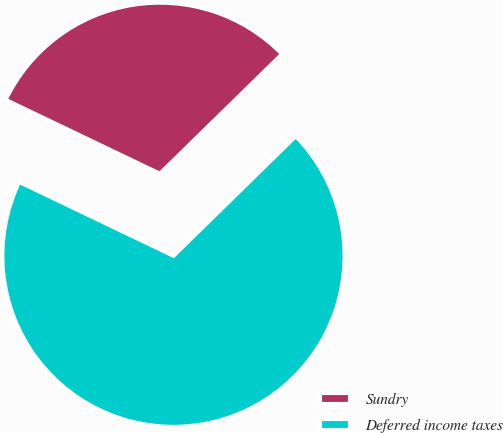Convert chart. <chart><loc_0><loc_0><loc_500><loc_500><pie_chart><fcel>Sundry<fcel>Deferred income taxes<nl><fcel>30.56%<fcel>69.44%<nl></chart> 